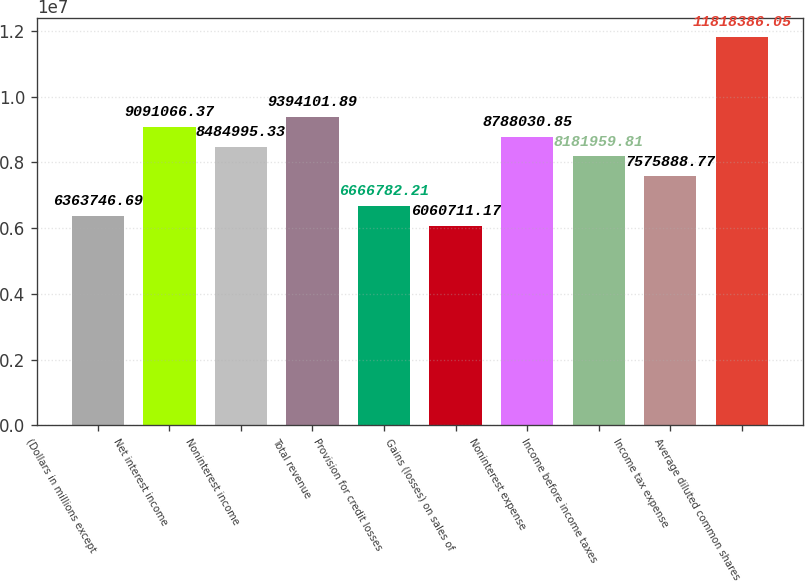Convert chart to OTSL. <chart><loc_0><loc_0><loc_500><loc_500><bar_chart><fcel>(Dollars in millions except<fcel>Net interest income<fcel>Noninterest income<fcel>Total revenue<fcel>Provision for credit losses<fcel>Gains (losses) on sales of<fcel>Noninterest expense<fcel>Income before income taxes<fcel>Income tax expense<fcel>Average diluted common shares<nl><fcel>6.36375e+06<fcel>9.09107e+06<fcel>8.485e+06<fcel>9.3941e+06<fcel>6.66678e+06<fcel>6.06071e+06<fcel>8.78803e+06<fcel>8.18196e+06<fcel>7.57589e+06<fcel>1.18184e+07<nl></chart> 